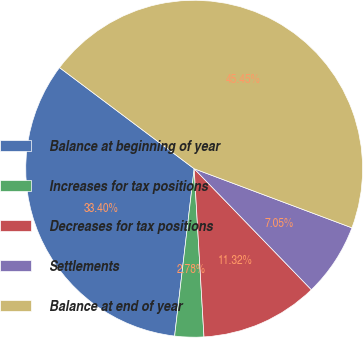Convert chart. <chart><loc_0><loc_0><loc_500><loc_500><pie_chart><fcel>Balance at beginning of year<fcel>Increases for tax positions<fcel>Decreases for tax positions<fcel>Settlements<fcel>Balance at end of year<nl><fcel>33.4%<fcel>2.78%<fcel>11.32%<fcel>7.05%<fcel>45.45%<nl></chart> 